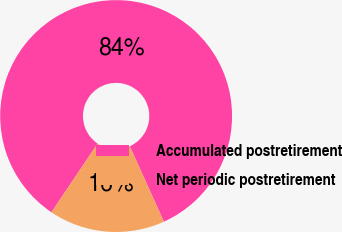<chart> <loc_0><loc_0><loc_500><loc_500><pie_chart><fcel>Accumulated postretirement<fcel>Net periodic postretirement<nl><fcel>83.83%<fcel>16.17%<nl></chart> 